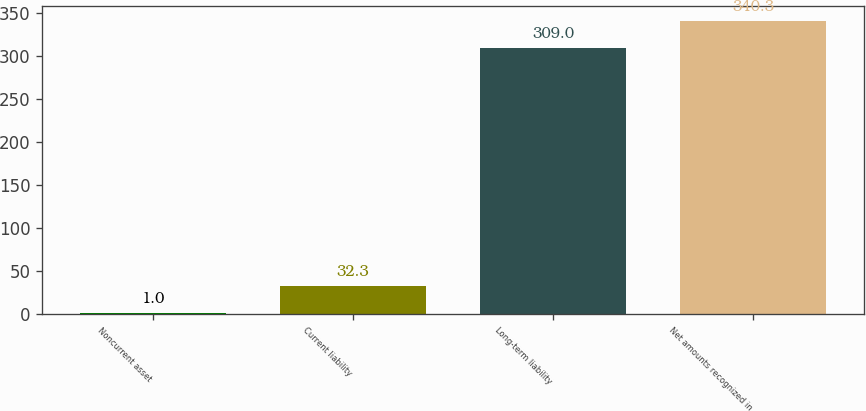Convert chart. <chart><loc_0><loc_0><loc_500><loc_500><bar_chart><fcel>Noncurrent asset<fcel>Current liability<fcel>Long-term liability<fcel>Net amounts recognized in<nl><fcel>1<fcel>32.3<fcel>309<fcel>340.3<nl></chart> 